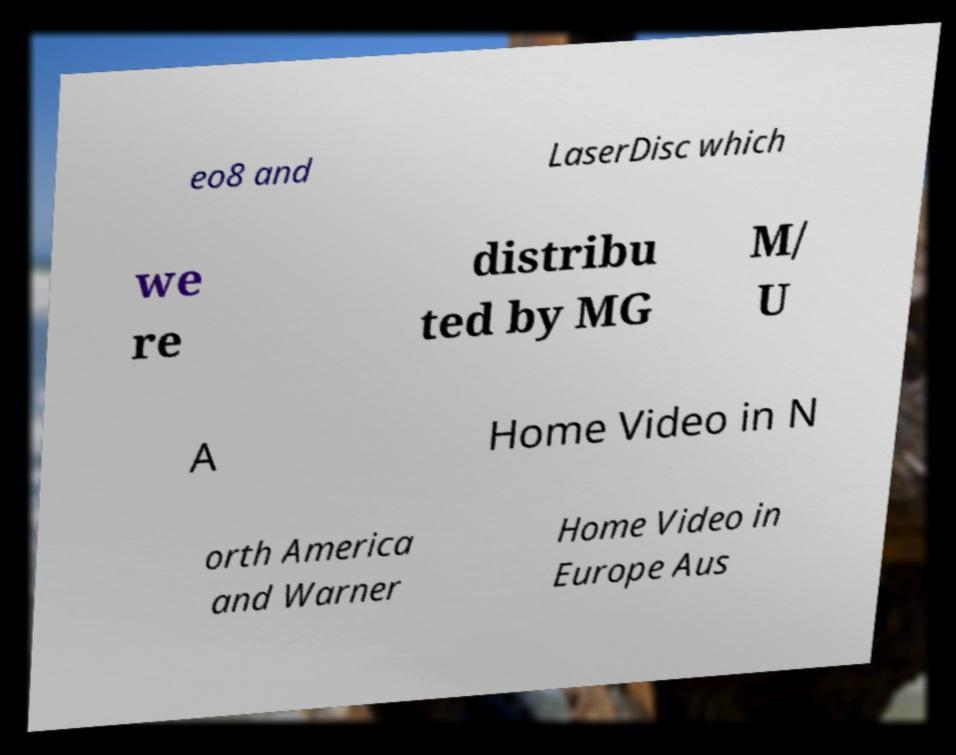Can you accurately transcribe the text from the provided image for me? eo8 and LaserDisc which we re distribu ted by MG M/ U A Home Video in N orth America and Warner Home Video in Europe Aus 